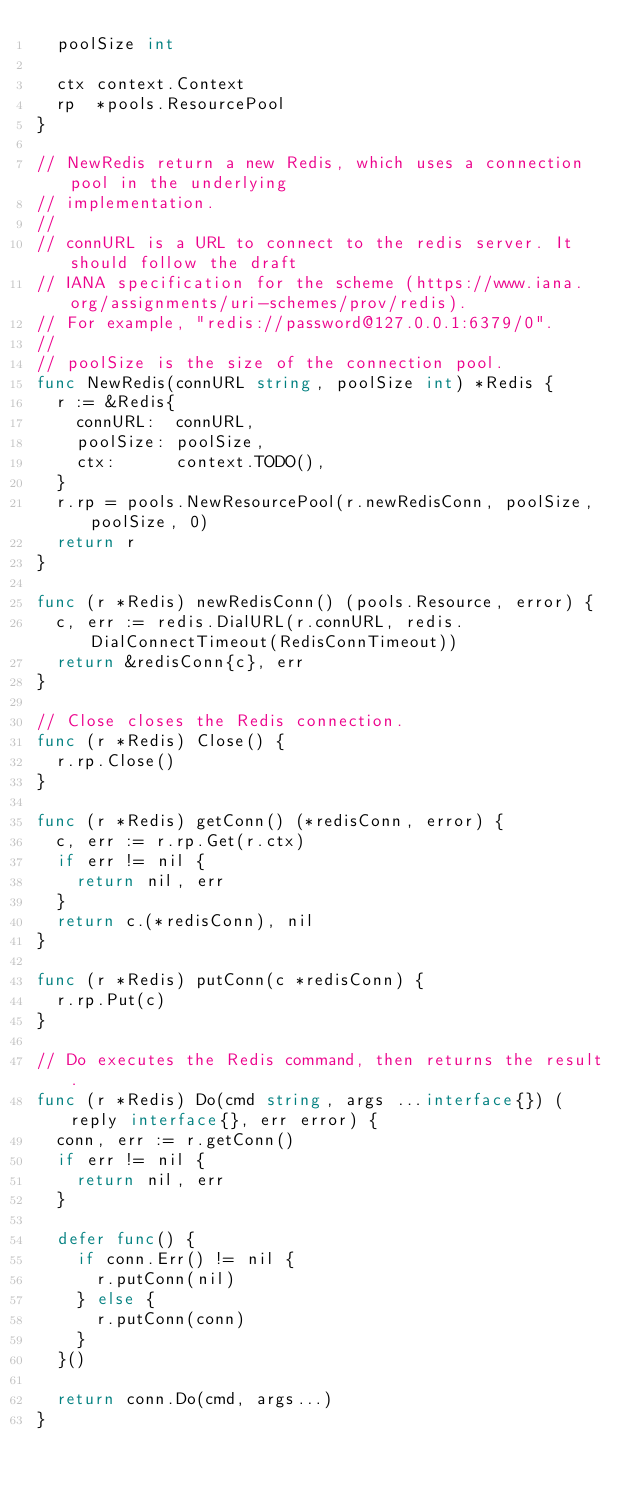<code> <loc_0><loc_0><loc_500><loc_500><_Go_>	poolSize int

	ctx context.Context
	rp  *pools.ResourcePool
}

// NewRedis return a new Redis, which uses a connection pool in the underlying
// implementation.
//
// connURL is a URL to connect to the redis server. It should follow the draft
// IANA specification for the scheme (https://www.iana.org/assignments/uri-schemes/prov/redis).
// For example, "redis://password@127.0.0.1:6379/0".
//
// poolSize is the size of the connection pool.
func NewRedis(connURL string, poolSize int) *Redis {
	r := &Redis{
		connURL:  connURL,
		poolSize: poolSize,
		ctx:      context.TODO(),
	}
	r.rp = pools.NewResourcePool(r.newRedisConn, poolSize, poolSize, 0)
	return r
}

func (r *Redis) newRedisConn() (pools.Resource, error) {
	c, err := redis.DialURL(r.connURL, redis.DialConnectTimeout(RedisConnTimeout))
	return &redisConn{c}, err
}

// Close closes the Redis connection.
func (r *Redis) Close() {
	r.rp.Close()
}

func (r *Redis) getConn() (*redisConn, error) {
	c, err := r.rp.Get(r.ctx)
	if err != nil {
		return nil, err
	}
	return c.(*redisConn), nil
}

func (r *Redis) putConn(c *redisConn) {
	r.rp.Put(c)
}

// Do executes the Redis command, then returns the result.
func (r *Redis) Do(cmd string, args ...interface{}) (reply interface{}, err error) {
	conn, err := r.getConn()
	if err != nil {
		return nil, err
	}

	defer func() {
		if conn.Err() != nil {
			r.putConn(nil)
		} else {
			r.putConn(conn)
		}
	}()

	return conn.Do(cmd, args...)
}
</code> 